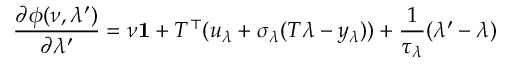Convert formula to latex. <formula><loc_0><loc_0><loc_500><loc_500>\frac { \partial \phi ( \nu , \lambda ^ { \prime } ) } { \partial \lambda ^ { \prime } } = \nu 1 + T ^ { \top } ( u _ { \lambda } + \sigma _ { \lambda } ( T \lambda - y _ { \lambda } ) ) + \frac { 1 } { \tau _ { \lambda } } ( \lambda ^ { \prime } - \lambda )</formula> 